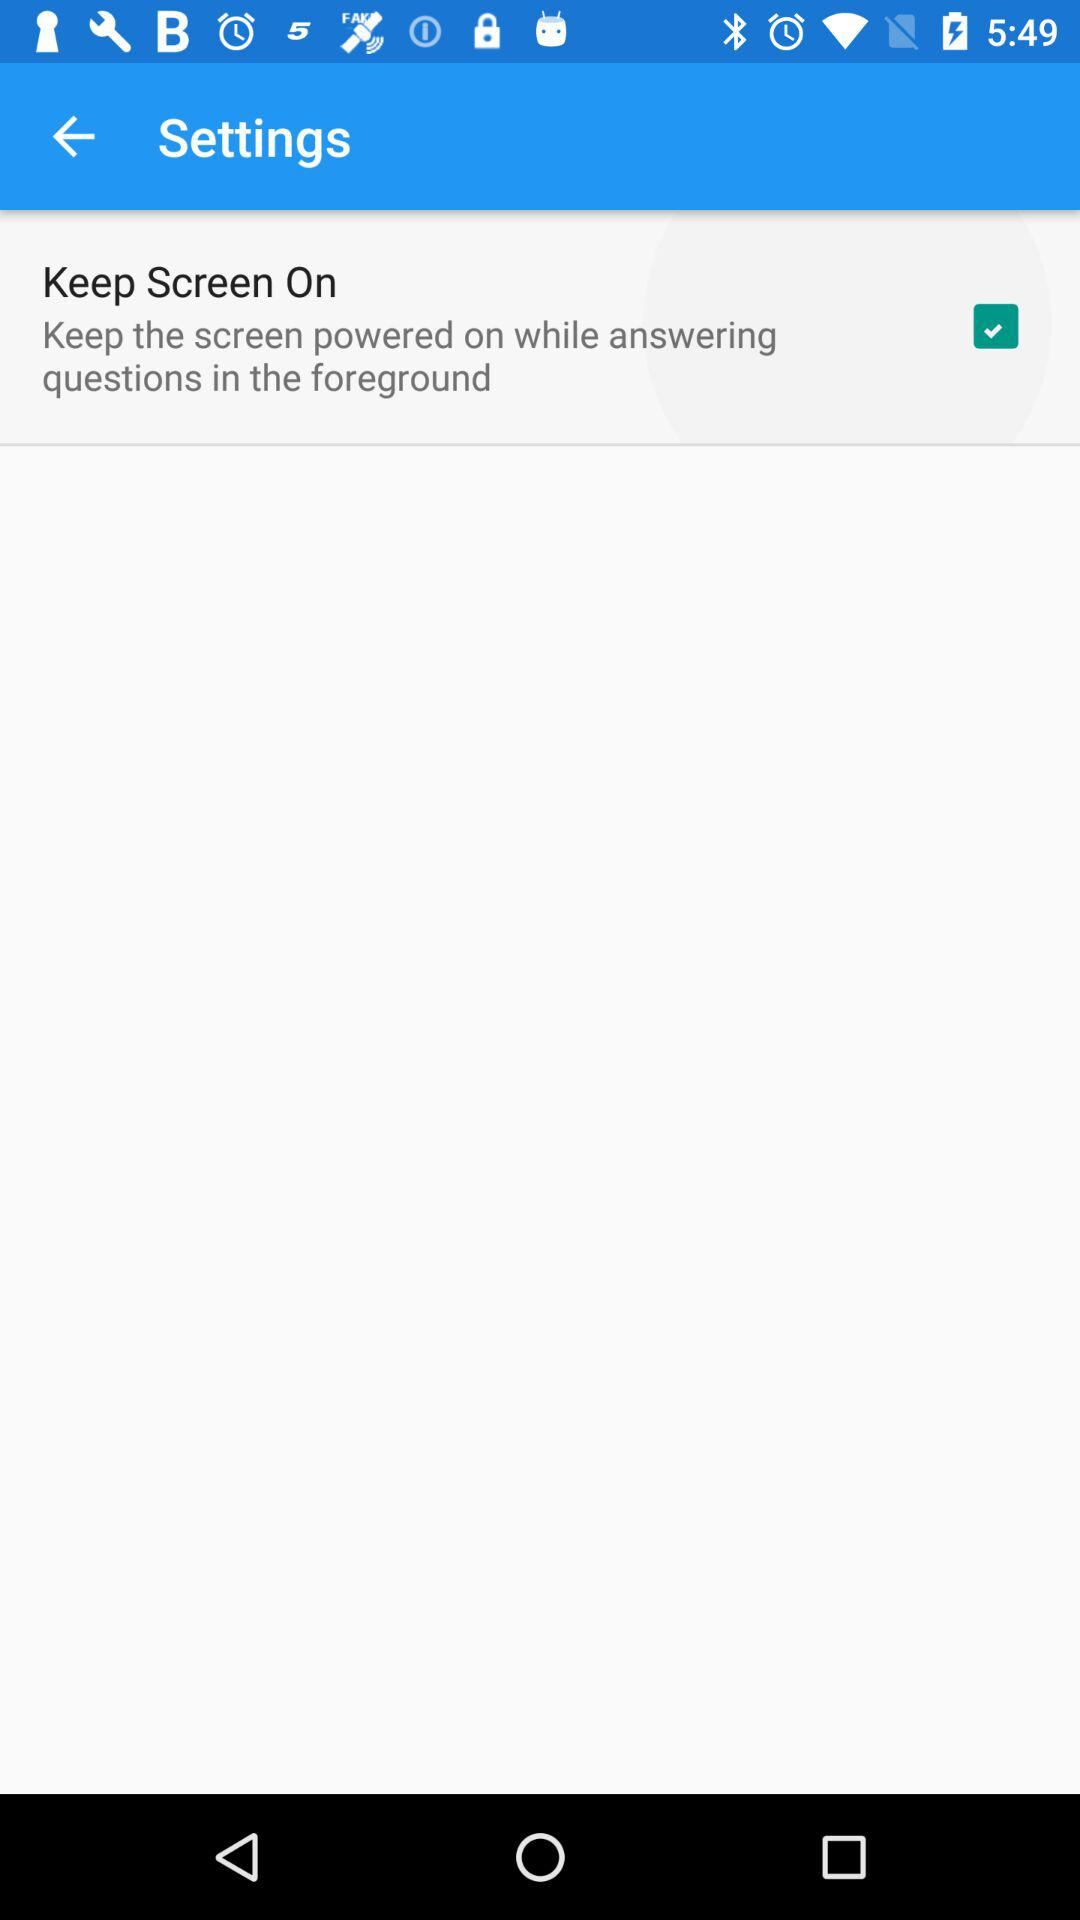What is the setting for Keep Screen On? The setting is on. 